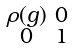<formula> <loc_0><loc_0><loc_500><loc_500>\begin{smallmatrix} \rho ( g ) & 0 \\ 0 & 1 \end{smallmatrix}</formula> 